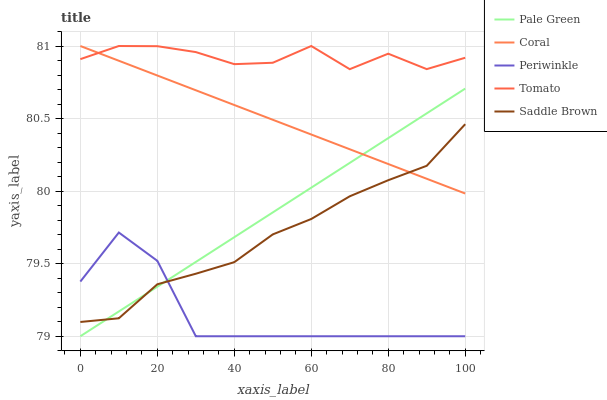Does Coral have the minimum area under the curve?
Answer yes or no. No. Does Coral have the maximum area under the curve?
Answer yes or no. No. Is Pale Green the smoothest?
Answer yes or no. No. Is Pale Green the roughest?
Answer yes or no. No. Does Coral have the lowest value?
Answer yes or no. No. Does Pale Green have the highest value?
Answer yes or no. No. Is Saddle Brown less than Tomato?
Answer yes or no. Yes. Is Tomato greater than Periwinkle?
Answer yes or no. Yes. Does Saddle Brown intersect Tomato?
Answer yes or no. No. 